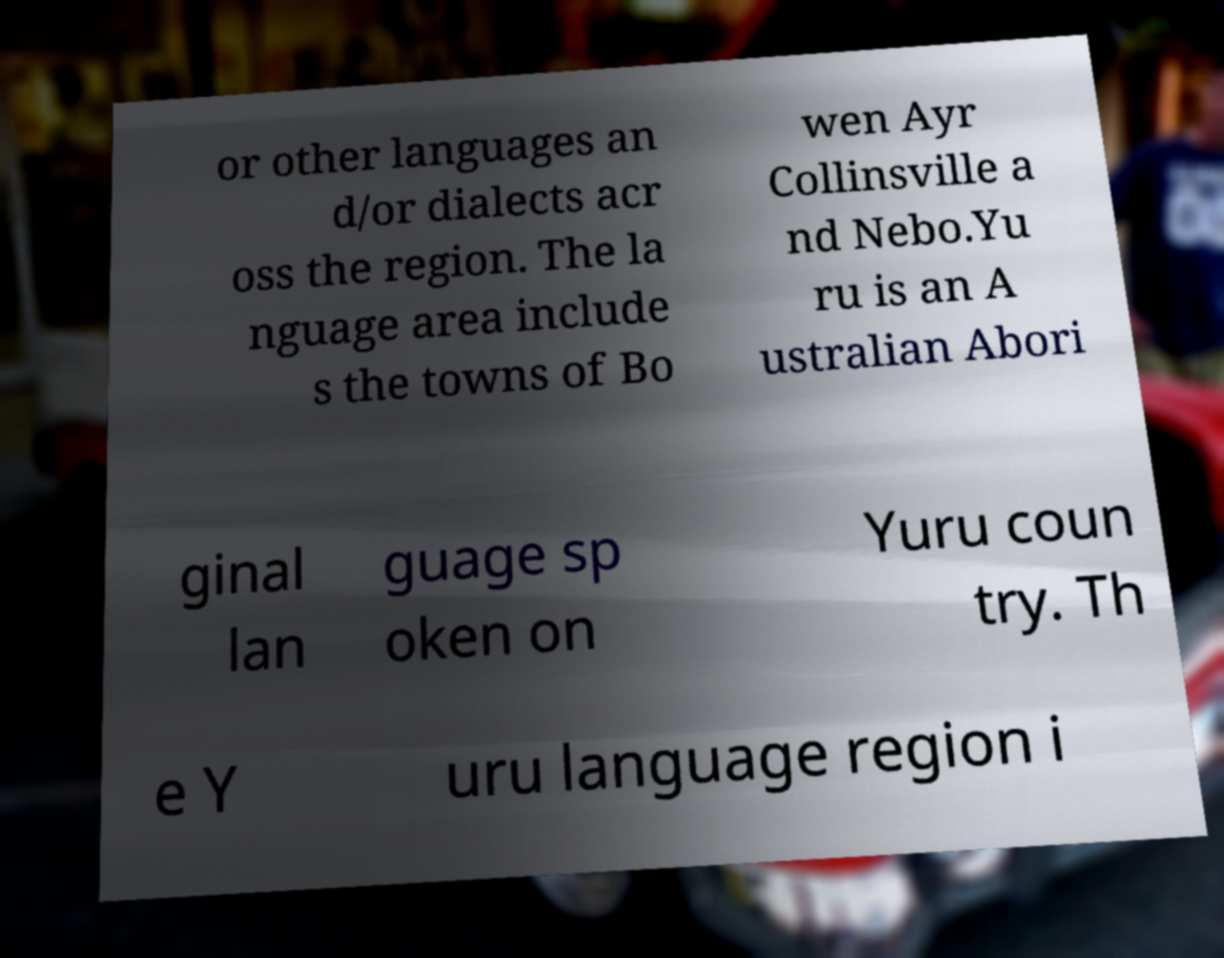Please identify and transcribe the text found in this image. or other languages an d/or dialects acr oss the region. The la nguage area include s the towns of Bo wen Ayr Collinsville a nd Nebo.Yu ru is an A ustralian Abori ginal lan guage sp oken on Yuru coun try. Th e Y uru language region i 